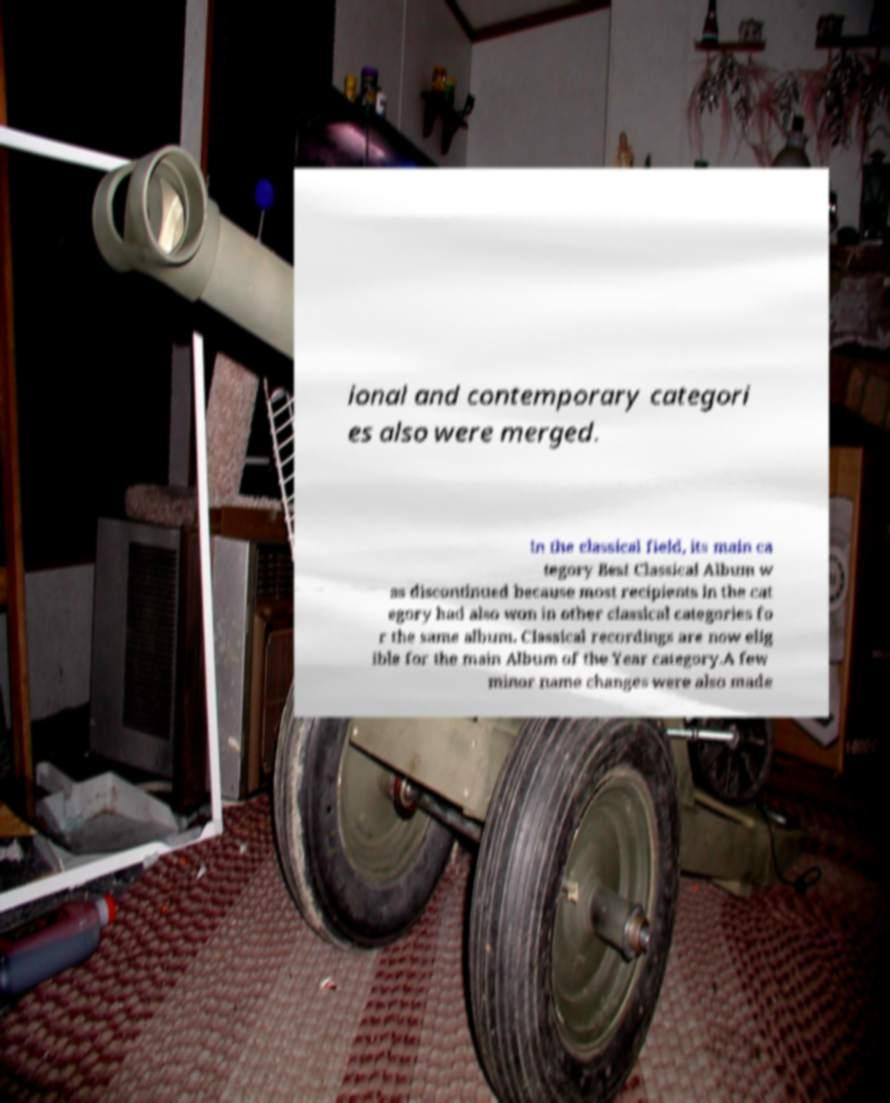I need the written content from this picture converted into text. Can you do that? ional and contemporary categori es also were merged. In the classical field, its main ca tegory Best Classical Album w as discontinued because most recipients in the cat egory had also won in other classical categories fo r the same album. Classical recordings are now elig ible for the main Album of the Year category.A few minor name changes were also made 